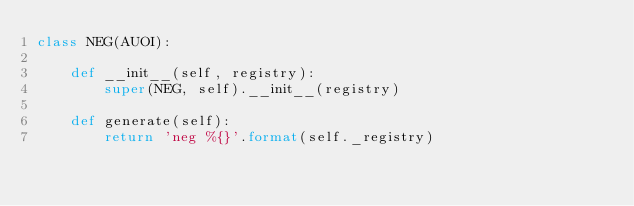Convert code to text. <code><loc_0><loc_0><loc_500><loc_500><_Python_>class NEG(AUOI):

    def __init__(self, registry):
        super(NEG, self).__init__(registry)

    def generate(self):
        return 'neg %{}'.format(self._registry)
</code> 